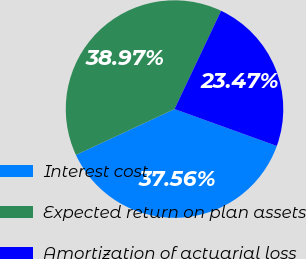<chart> <loc_0><loc_0><loc_500><loc_500><pie_chart><fcel>Interest cost<fcel>Expected return on plan assets<fcel>Amortization of actuarial loss<nl><fcel>37.56%<fcel>38.97%<fcel>23.47%<nl></chart> 